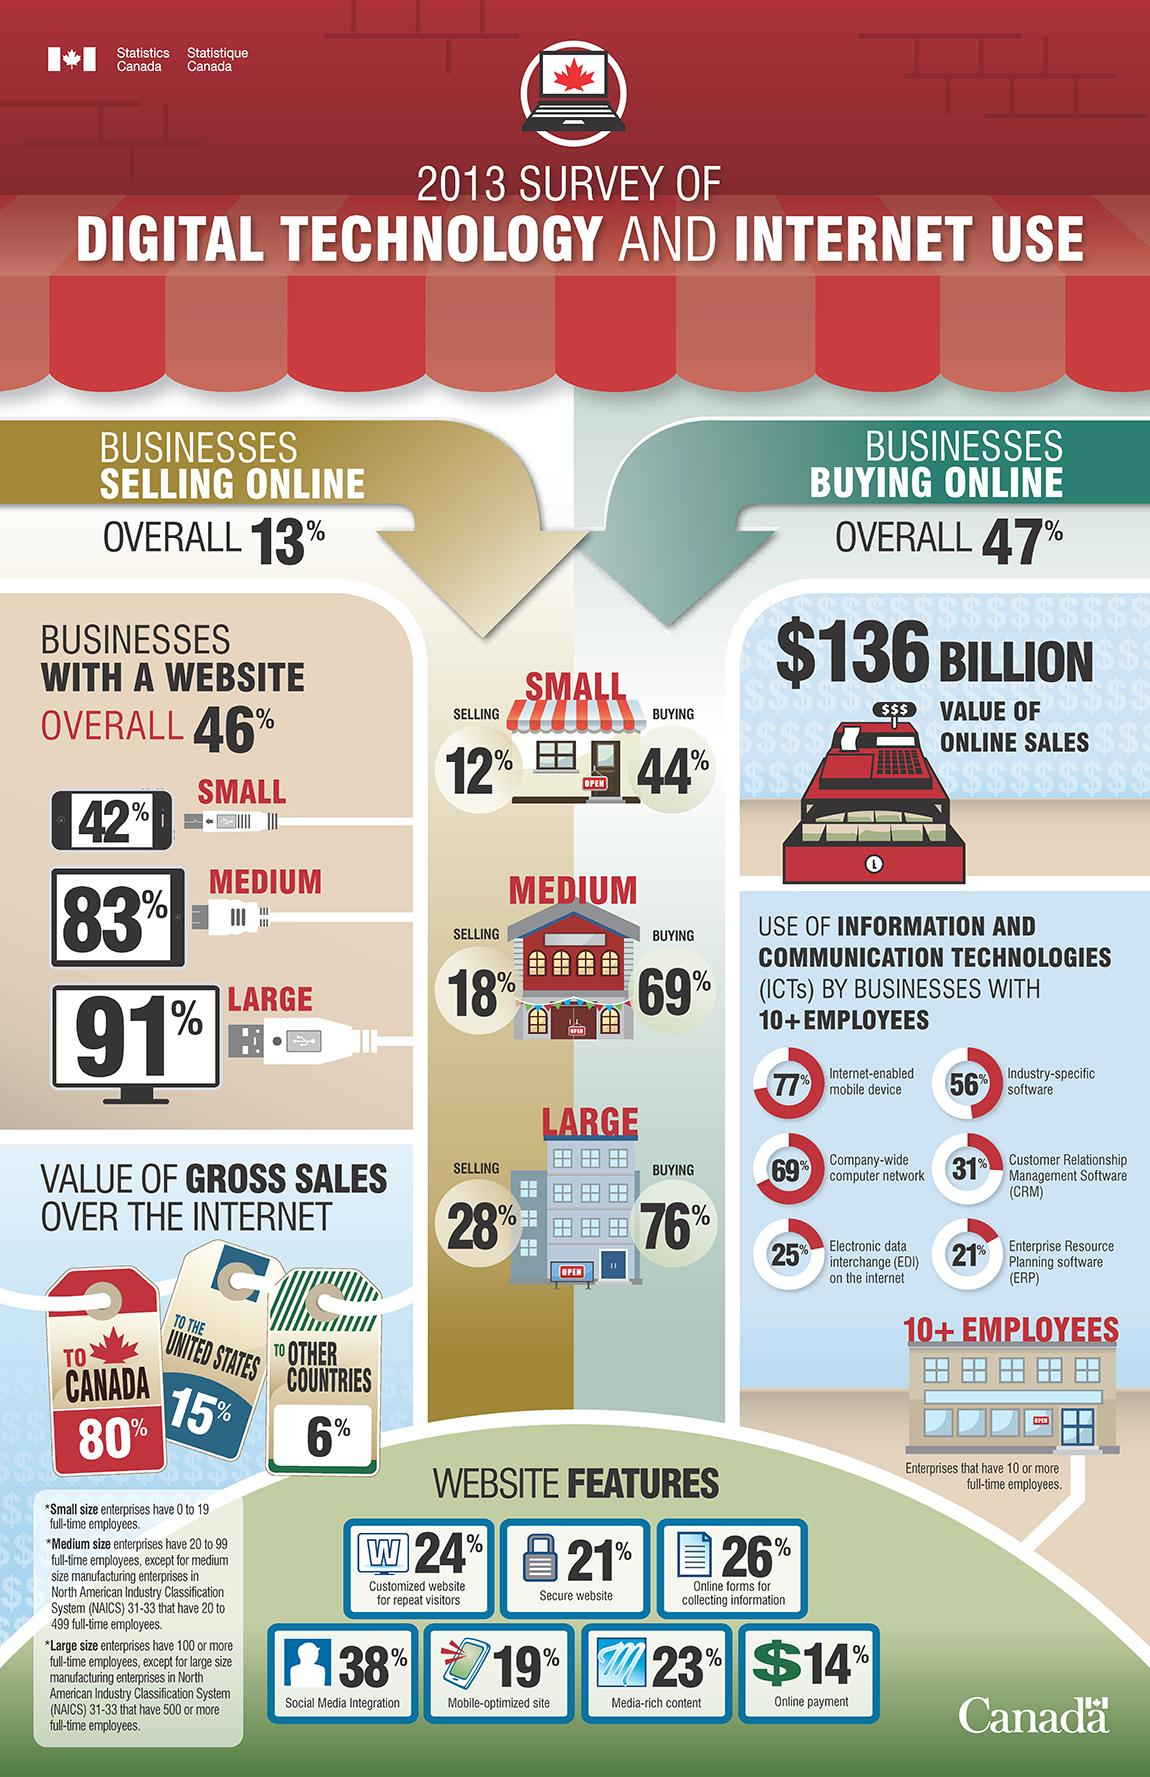Draw attention to some important aspects in this diagram. According to a survey conducted in 2013, the value of gross sales made over the internet in Canada was 80% of the total gross sales. According to a survey conducted in 2013, the value of gross sales made over the internet to the United States was approximately 15%. According to a survey conducted in Canada in 2013, approximately 21% of businesses with 10 or more employees used ERP software. According to a survey conducted in 2013, Enterprise Resource Planning (ERP) software is the least commonly used Information and Communication Technology by businesses with 10 or more employees in Canada. In 2013, a significant majority (91%) of large-scale enterprises in Canada that had a website, reported that it accounted for a significant portion of their overall sales. 